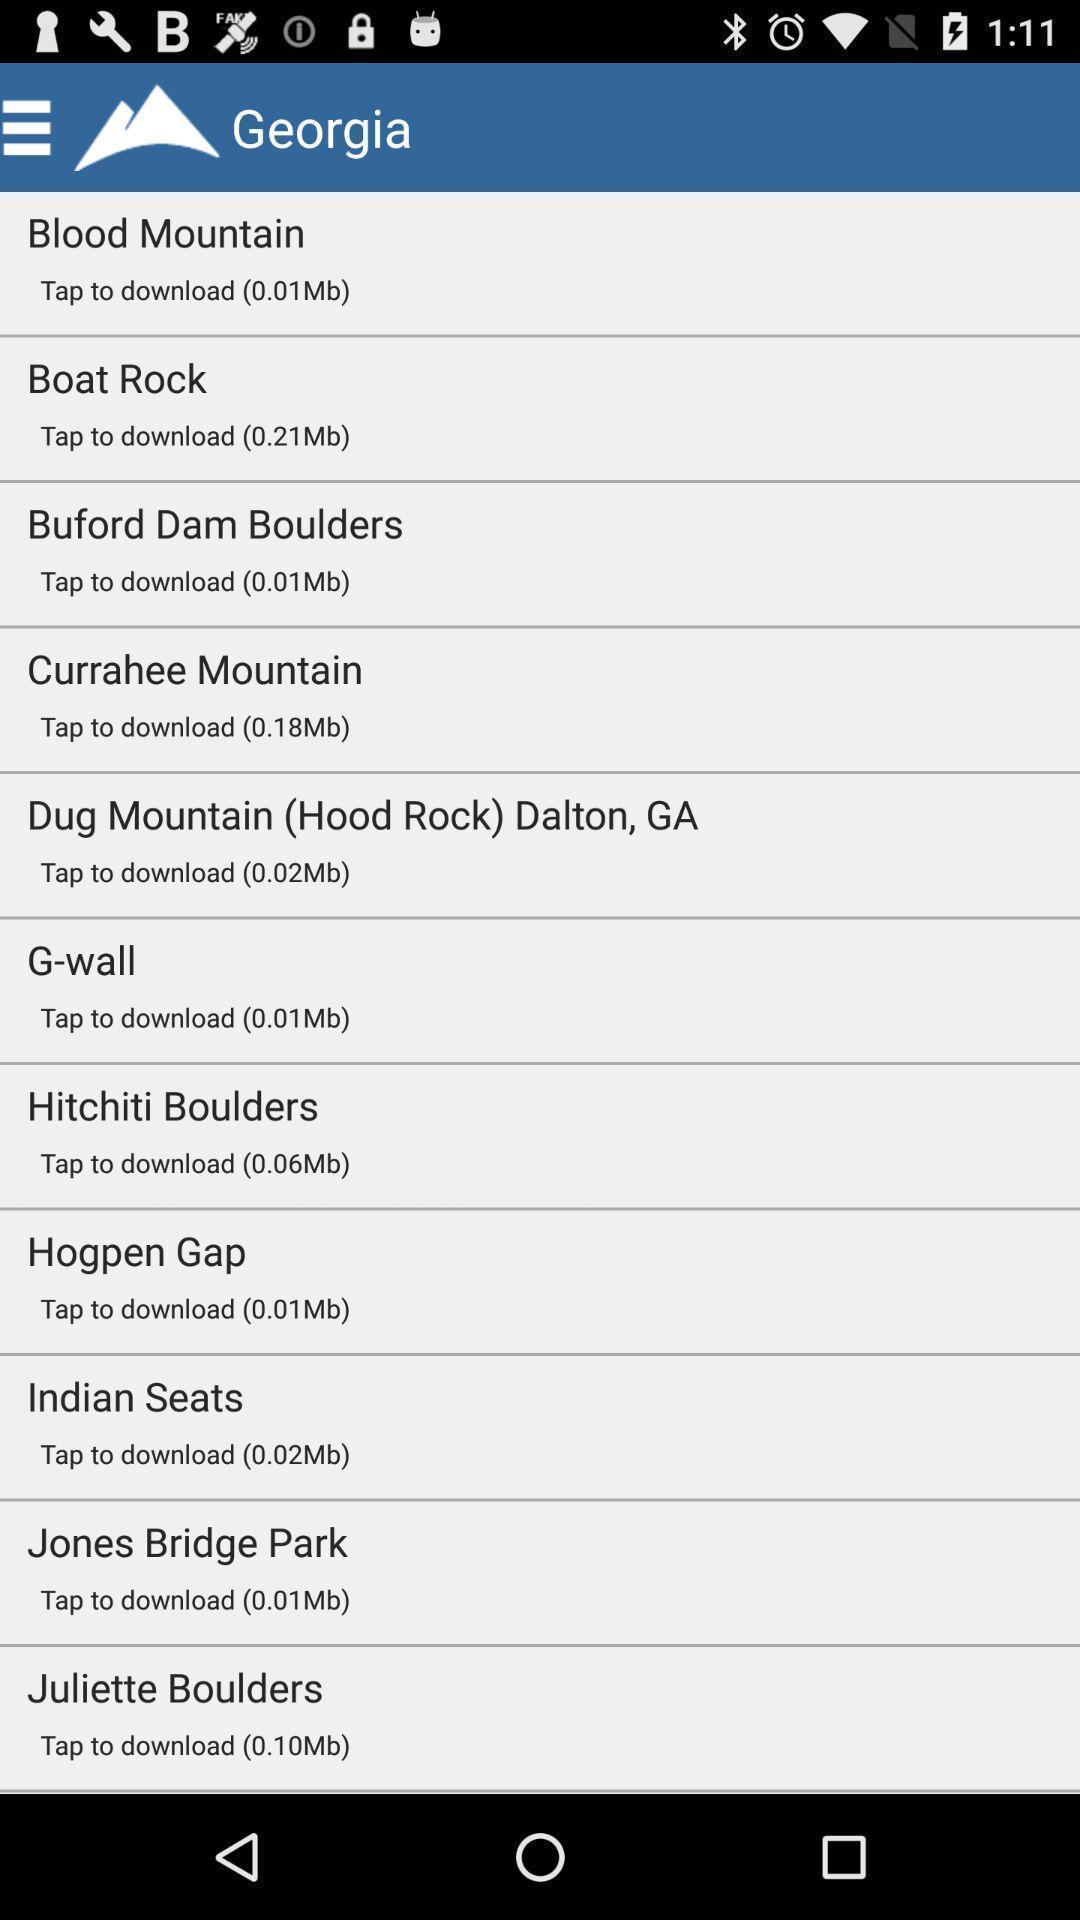What is the overall content of this screenshot? Page to find climbing areas from the list. 